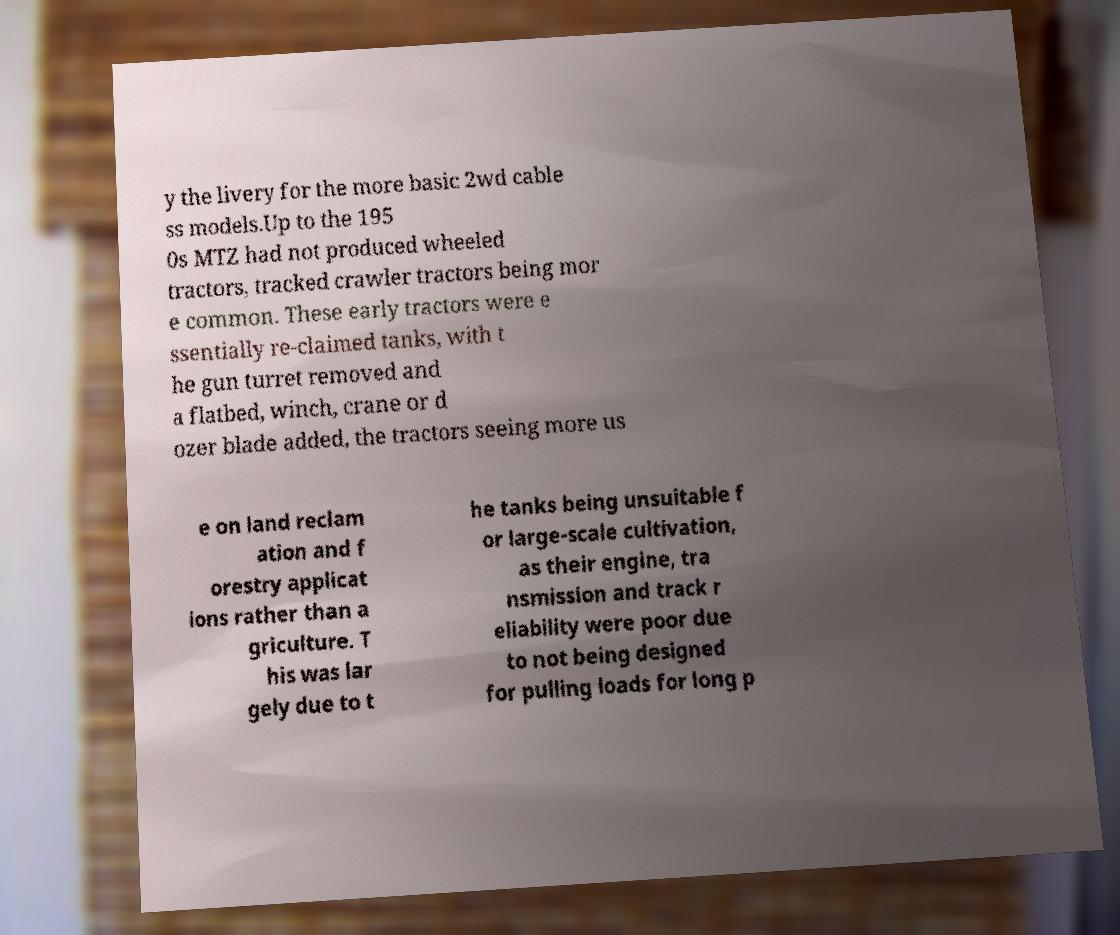Could you assist in decoding the text presented in this image and type it out clearly? y the livery for the more basic 2wd cable ss models.Up to the 195 0s MTZ had not produced wheeled tractors, tracked crawler tractors being mor e common. These early tractors were e ssentially re-claimed tanks, with t he gun turret removed and a flatbed, winch, crane or d ozer blade added, the tractors seeing more us e on land reclam ation and f orestry applicat ions rather than a griculture. T his was lar gely due to t he tanks being unsuitable f or large-scale cultivation, as their engine, tra nsmission and track r eliability were poor due to not being designed for pulling loads for long p 